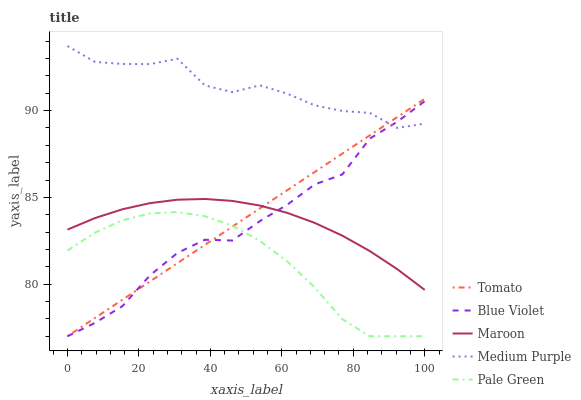Does Pale Green have the minimum area under the curve?
Answer yes or no. Yes. Does Medium Purple have the maximum area under the curve?
Answer yes or no. Yes. Does Medium Purple have the minimum area under the curve?
Answer yes or no. No. Does Pale Green have the maximum area under the curve?
Answer yes or no. No. Is Tomato the smoothest?
Answer yes or no. Yes. Is Medium Purple the roughest?
Answer yes or no. Yes. Is Pale Green the smoothest?
Answer yes or no. No. Is Pale Green the roughest?
Answer yes or no. No. Does Medium Purple have the lowest value?
Answer yes or no. No. Does Pale Green have the highest value?
Answer yes or no. No. Is Pale Green less than Maroon?
Answer yes or no. Yes. Is Medium Purple greater than Pale Green?
Answer yes or no. Yes. Does Pale Green intersect Maroon?
Answer yes or no. No. 